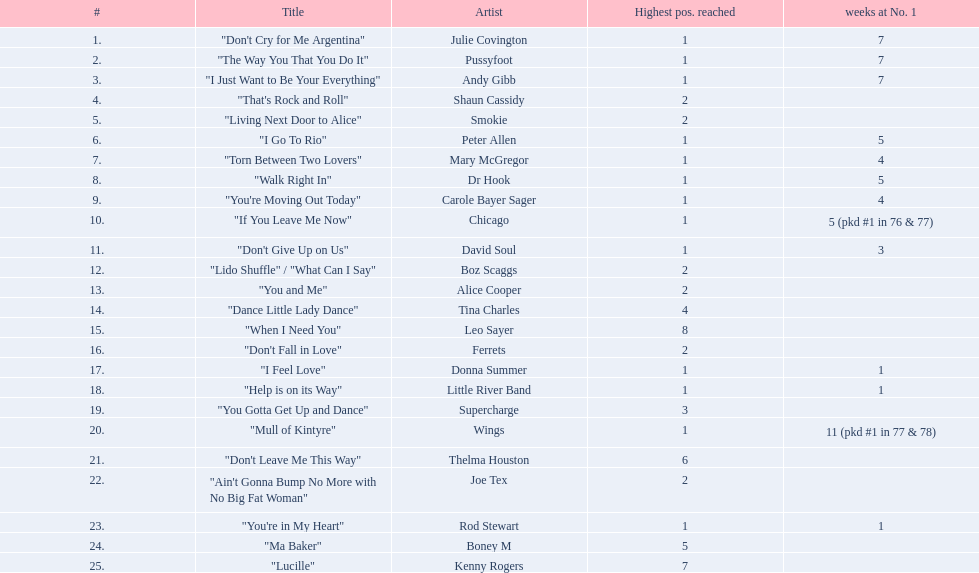What was the number of weeks that julie covington's single " don't cry for me argentinia," was at number 1 in 1977? 7. 